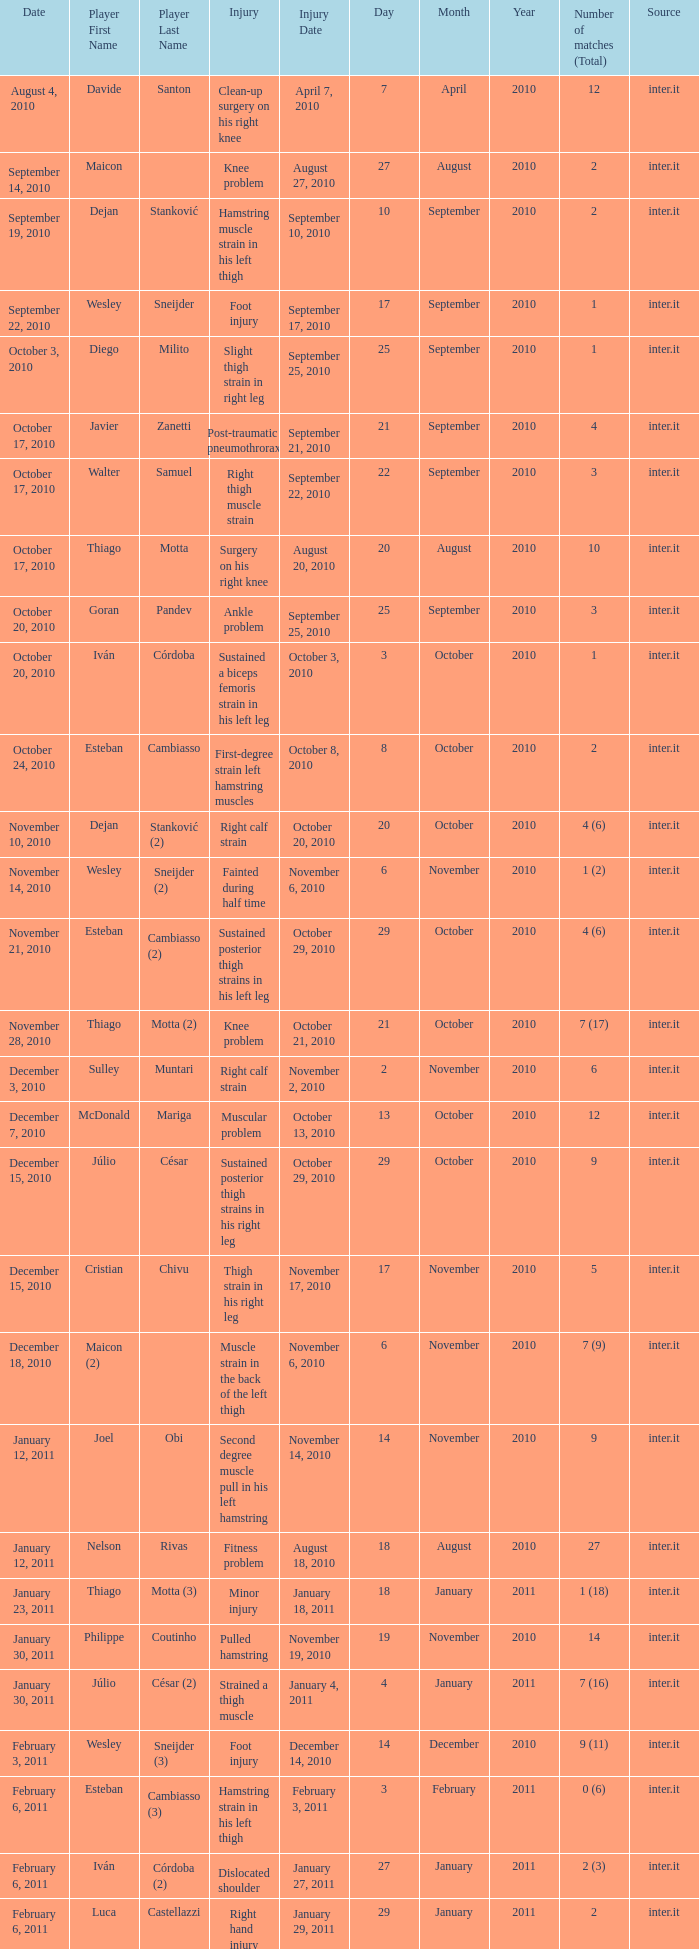What is the date of injury for player Wesley sneijder (2)? November 6, 2010. 